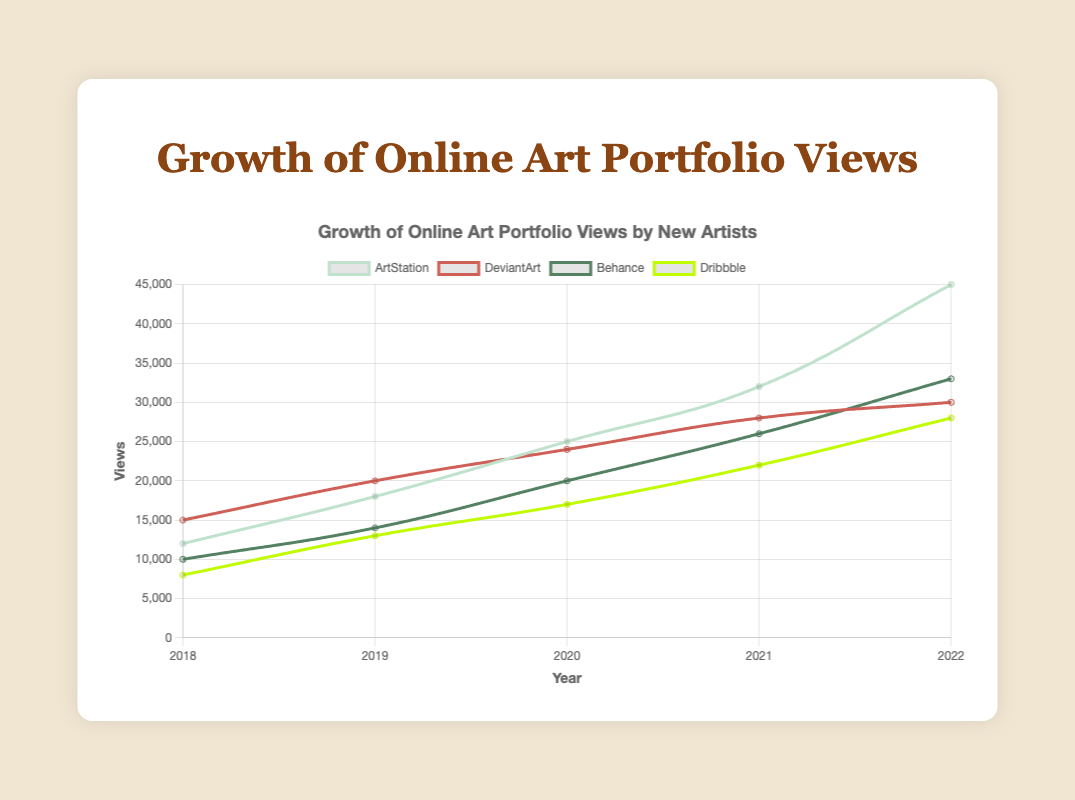What's the total number of views in 2022 across all portfolio sites? Add the views from ArtStation, DeviantArt, Behance, and Dribbble for the year 2022: 45000 (ArtStation) + 30000 (DeviantArt) + 33000 (Behance) + 28000 (Dribbble) = 136000
Answer: 136000 Which portfolio site saw the highest growth in views from 2018 to 2022? Subtract 2018 views from 2022 views for each site and compare: ArtStation (45000 - 12000 = 33000), DeviantArt (30000 - 15000 = 15000), Behance (33000 - 10000 = 23000), Dribbble (28000 - 8000 = 20000). ArtStation has the highest growth of 33000 views
Answer: ArtStation In 2020, which portfolio site had the least number of views and how many? Check the views for each site in 2020: ArtStation (25000), DeviantArt (24000), Behance (20000), Dribbble (17000). Dribbble has the least number of views with 17000
Answer: Dribbble with 17000 views By what percentage did ArtStation's views increase from 2019 to 2020? Calculate the percentage increase: ((25000 - 18000) / 18000) * 100 = 38.89%
Answer: 38.89% Which year did Behance surpass DeviantArt in views for the first time? Compare the views year by year: In 2020, Behance (20000) surpassed DeviantArt (24000). But in 2021, Behance (26000) was still behind DeviantArt (28000). In 2022, Behance (33000) finally surpassed DeviantArt (30000)
Answer: 2022 Did any portfolio site have a consistent increase in views every year? Analyze the yearly views for each site:
- ArtStation: 12000 -> 18000 -> 25000 -> 32000 -> 45000 (consistent increase)
- DeviantArt: 15000 -> 20000 -> 24000 -> 28000 -> 30000 (consistent increase)
- Behance: 10000 -> 14000 -> 20000 -> 26000 -> 33000 (consistent increase)
- Dribbble: 8000 -> 13000 -> 17000 -> 22000 -> 28000 (consistent increase)
All sites have a consistent increase every year
Answer: Yes, all sites What is the average annual growth for DeviantArt from 2018 to 2022? Calculate the annual growth for DeviantArt: (20000 - 15000 = 5000 for 2019), (24000 - 20000 = 4000 for 2020), (28000 - 24000 = 4000 for 2021), (30000 - 28000 = 2000 for 2022). Average growth = (5000 + 4000 + 4000 + 2000) / 4 = 3750 views per year
Answer: 3750 views per year In which year did ArtStation have the highest increase in views compared to the previous year? Compare the yearly increase: 2018-2019 (18000 - 12000 = 6000), 2019-2020 (25000 - 18000 = 7000), 2020-2021 (32000 - 25000 = 7000), 2021-2022 (45000 - 32000 = 13000). The highest increase is from 2021 to 2022
Answer: 2021 to 2022 